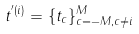<formula> <loc_0><loc_0><loc_500><loc_500>t ^ { ^ { \prime } ( i ) } = \{ t _ { c } \} _ { c = - M , c \neq i } ^ { M }</formula> 